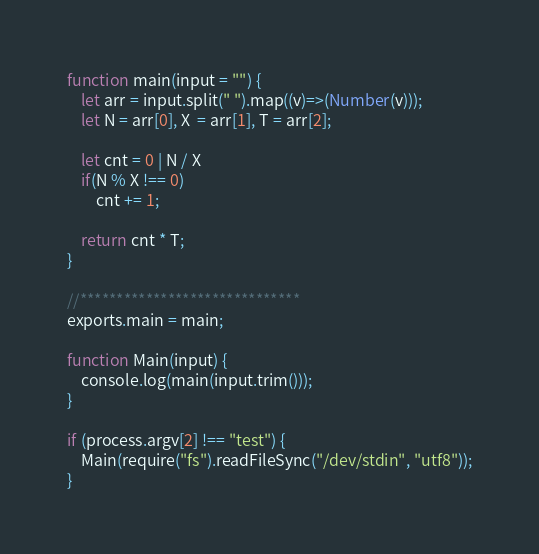<code> <loc_0><loc_0><loc_500><loc_500><_JavaScript_>function main(input = "") {
    let arr = input.split(" ").map((v)=>(Number(v)));
    let N = arr[0], X  = arr[1], T = arr[2];

    let cnt = 0 | N / X
    if(N % X !== 0)
        cnt += 1;
        
    return cnt * T;
}

//******************************
exports.main = main;

function Main(input) {
    console.log(main(input.trim()));
}

if (process.argv[2] !== "test") {
    Main(require("fs").readFileSync("/dev/stdin", "utf8"));
}
</code> 